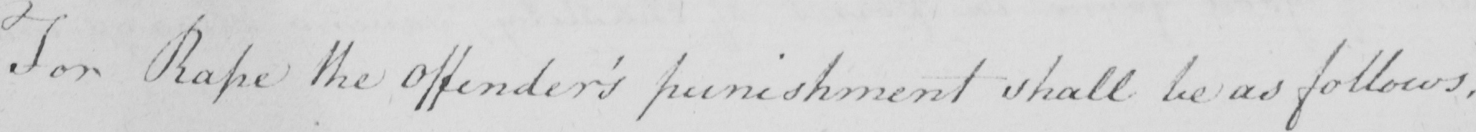Can you tell me what this handwritten text says? For Rape the offender ' s punishment shall be as follows : 